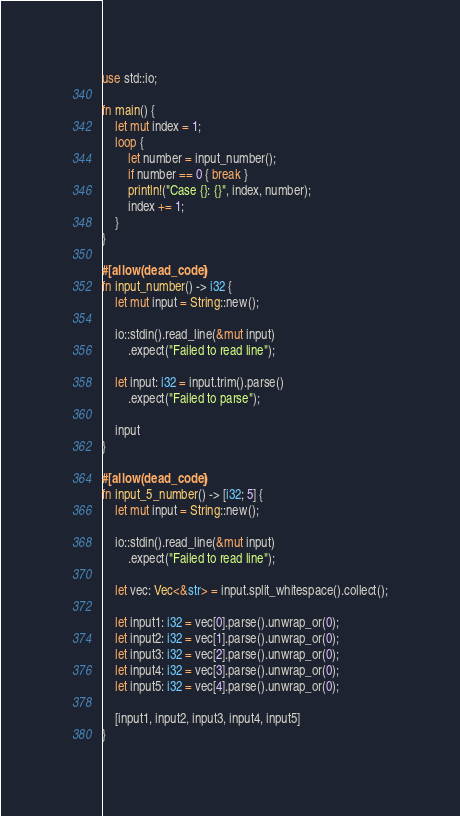<code> <loc_0><loc_0><loc_500><loc_500><_Rust_>use std::io;

fn main() {
    let mut index = 1;
    loop {
        let number = input_number();
        if number == 0 { break }
        println!("Case {}: {}", index, number);
        index += 1;
    }
}

#[allow(dead_code)]
fn input_number() -> i32 {
    let mut input = String::new();

    io::stdin().read_line(&mut input)
        .expect("Failed to read line");

    let input: i32 = input.trim().parse()
        .expect("Failed to parse");
    
    input
}

#[allow(dead_code)]
fn input_5_number() -> [i32; 5] {
    let mut input = String::new();

    io::stdin().read_line(&mut input)
        .expect("Failed to read line");

    let vec: Vec<&str> = input.split_whitespace().collect();

    let input1: i32 = vec[0].parse().unwrap_or(0);
    let input2: i32 = vec[1].parse().unwrap_or(0);
    let input3: i32 = vec[2].parse().unwrap_or(0);
    let input4: i32 = vec[3].parse().unwrap_or(0);
    let input5: i32 = vec[4].parse().unwrap_or(0);

    [input1, input2, input3, input4, input5]
}

</code> 